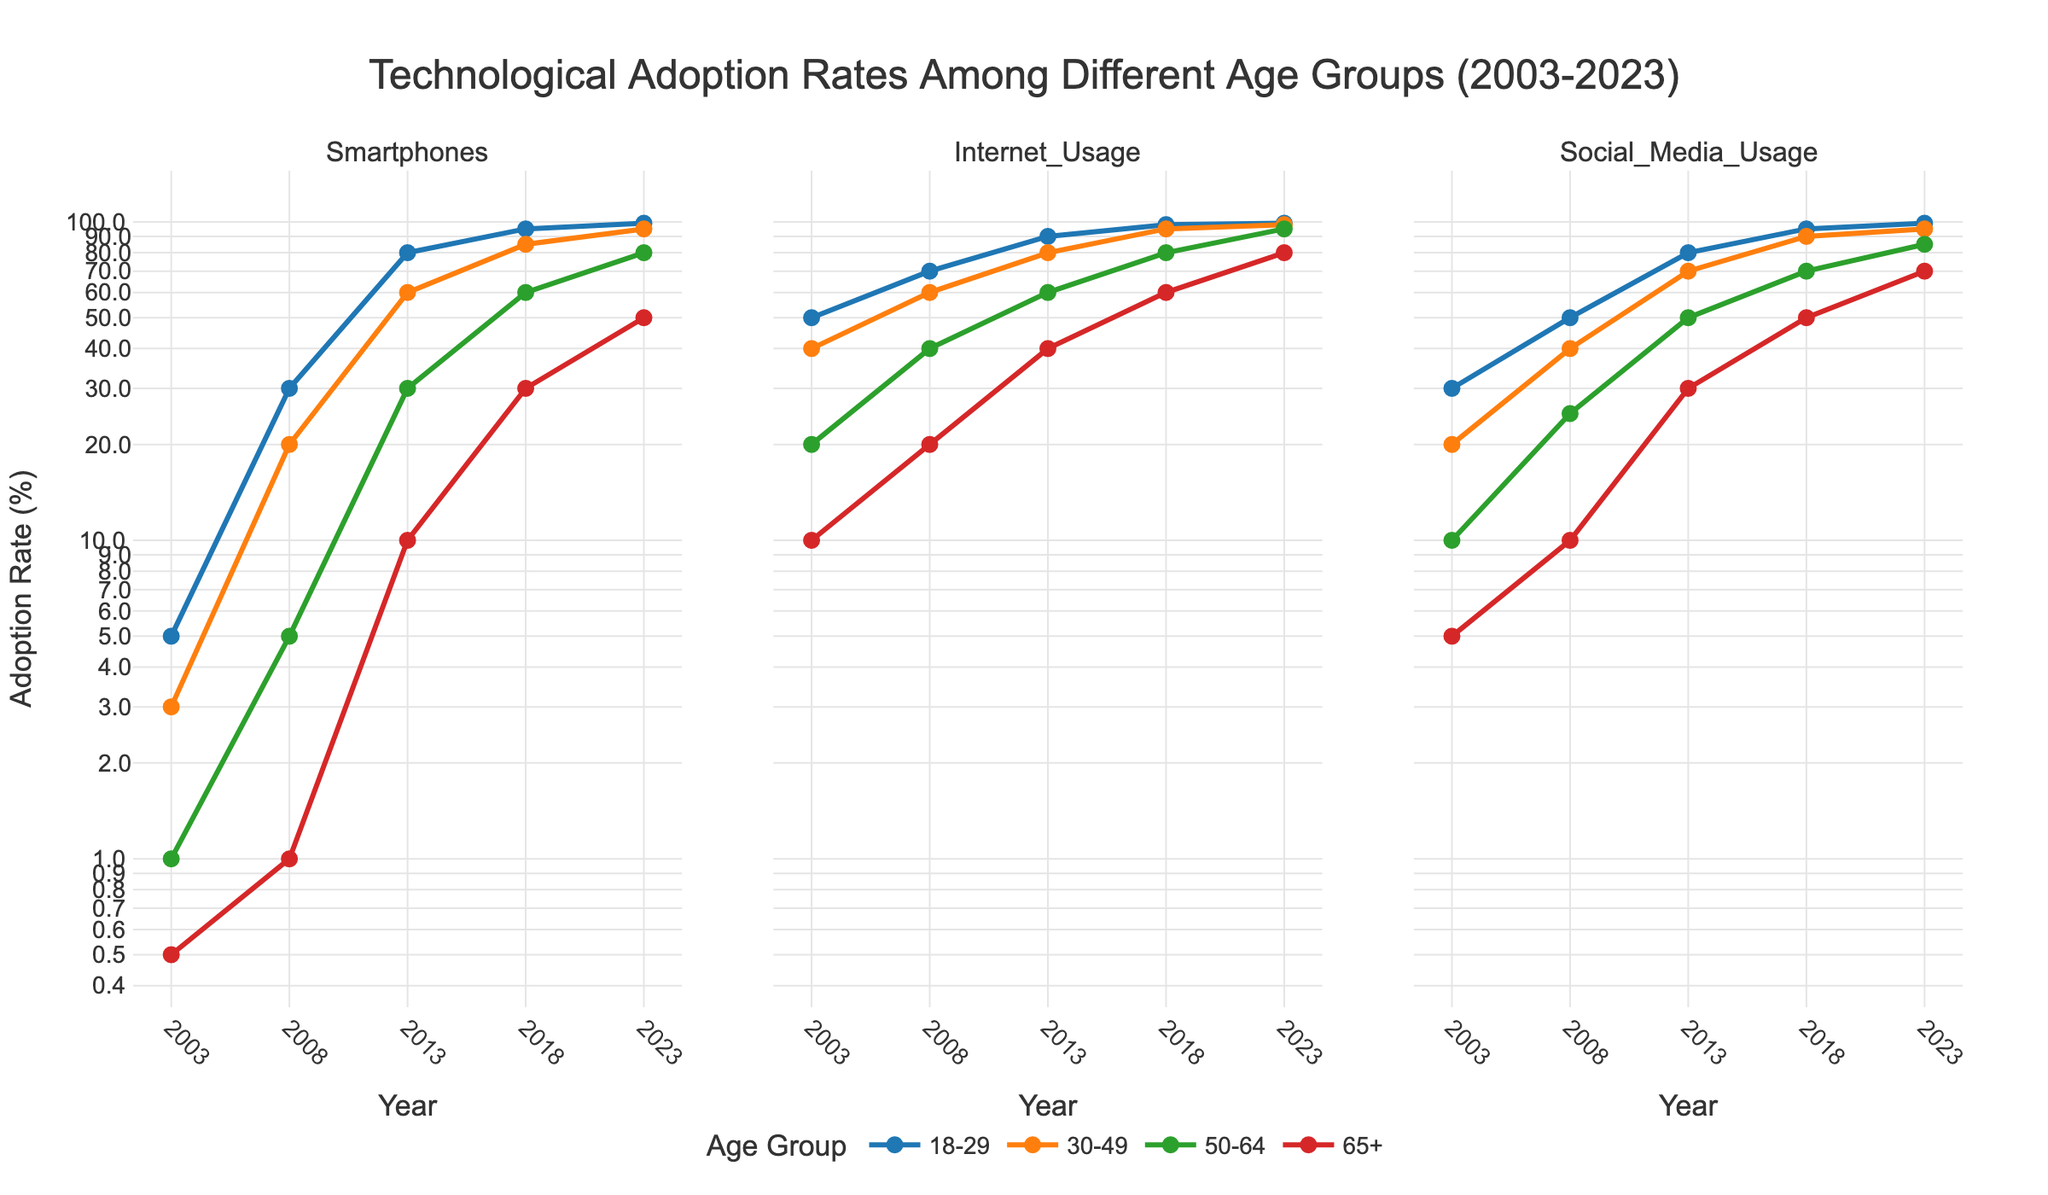What is the title of the figure? The title is usually located at the top of the figure. Here, it clearly states the subject of the plot: "Technological Adoption Rates Among Different Age Groups (2003-2023)"
Answer: Technological Adoption Rates Among Different Age Groups (2003-2023) What technology had the highest adoption rate in 2023 among the 18-29 age group? Look at the rightmost data points (year 2023) for the 18-29 age group line (color-coded) in each subplot. The values are given for Smartphones, Internet Usage, and Social Media Usage. All three show an adoption rate of 99%.
Answer: All technologies were adopted at a rate of 99% Which age group had the lowest adoption rate for Internet Usage in 2003? Look at the leftmost data points (year 2003) in the Internet Usage subplot. Check the y-values corresponding to each age group's line. The 65+ age group has the lowest value.
Answer: 65+ How did the adoption rate for Social Media Usage in the 50-64 age group change from 2008 to 2013? Locate the data points for the 50-64 age group line in 2008 and 2013 in the Social Media Usage subplot. Subtract the 2008 value (25%) from the 2013 value (50%).
Answer: Increased by 25% Which age group saw the greatest increase in Smartphone adoption from 2013 to 2018? Find the data points for each age group in 2013 and 2018 in the Smartphone subplot. Calculate the difference for each age group, then compare the increases. The 65+ age group increased from 10% to 30%.
Answer: 65+ What is the trend for Internet Usage adoption rates among the 65+ age group from 2003 to 2023? Observe the 65+ age group's line in the Internet Usage subplot. Starting from 10% in 2003, the trend shows a steady increase up to 80% in 2023.
Answer: Steady increase Compare the adoption rates of Social Media Usage between the 30-49 and 50-64 age groups in 2023. Look at the rightmost data points (year 2023) in the Social Media Usage subplot for the 30-49 and 50-64 age groups. The 30-49 group is at 95%, whereas the 50-64 group is at 85%.
Answer: 30-49 group: 95%, 50-64 group: 85% What is the axis type used for the y-axes in the subplots? The y-axes are type "log" which means they use a logarithmic scale, as indicated by the axis labels and the visual spacing of grid lines.
Answer: Logarithmic How does the adoption rate of Smartphones for the 18-29 age group in 2008 compare with the 30-49 age group in the same year? Locate the 2008 data points in the Smartphone subplot for both age groups. The 18-29 group is at 30%, while the 30-49 group is at 20%.
Answer: 18-29 group: 30%, 30-49 group: 20% What can we infer about the trend in Social Media Usage for the 18-29 age group across the years? Examine the 18-29 age group's line in the Social Media Usage subplot. The trend shows a rapid increase from 30% in 2003 to 99% in 2023, indicating strong adoption over time.
Answer: Rapid increase 